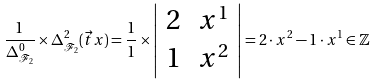Convert formula to latex. <formula><loc_0><loc_0><loc_500><loc_500>\frac { 1 } { \Delta _ { \mathcal { F } _ { 2 } } ^ { 0 } } \times \Delta _ { \mathcal { F } _ { 2 } } ^ { 2 } ( \vec { t } { x } ) = \frac { 1 } { 1 } \times \left | \begin{array} { c c } 2 & x ^ { 1 } \\ 1 & x ^ { 2 } \\ \end{array} \right | = 2 \cdot x ^ { 2 } - 1 \cdot x ^ { 1 } \in \mathbb { Z }</formula> 